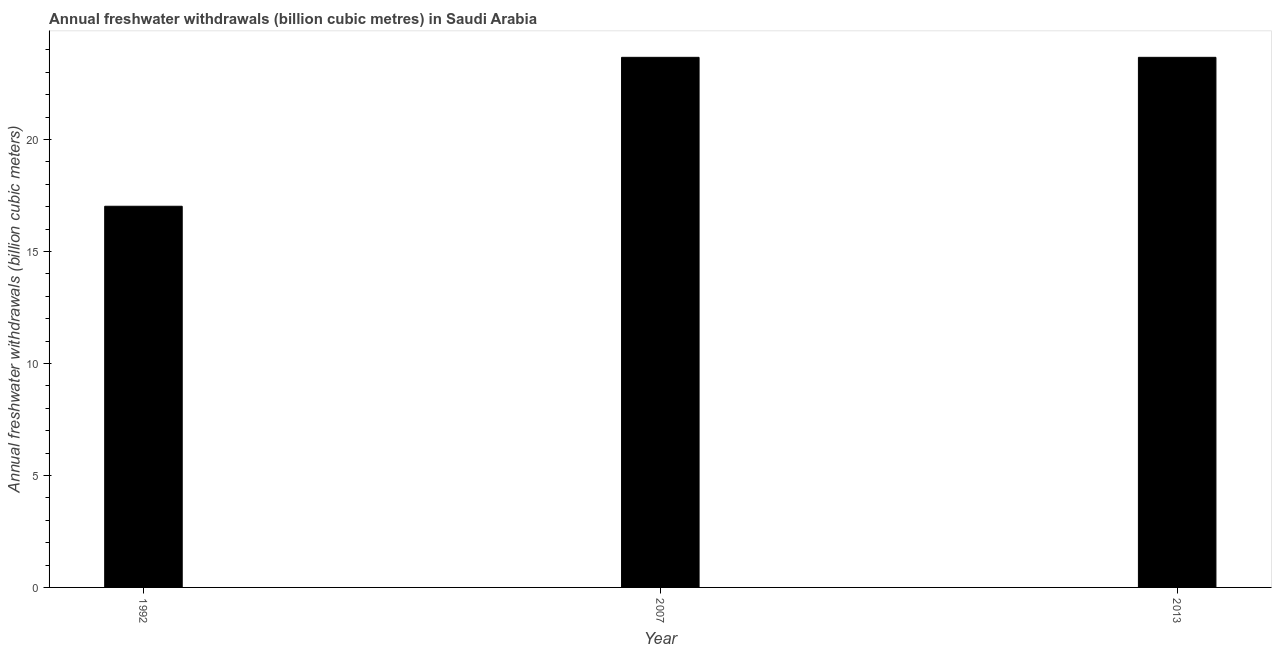Does the graph contain any zero values?
Offer a terse response. No. What is the title of the graph?
Give a very brief answer. Annual freshwater withdrawals (billion cubic metres) in Saudi Arabia. What is the label or title of the Y-axis?
Your response must be concise. Annual freshwater withdrawals (billion cubic meters). What is the annual freshwater withdrawals in 1992?
Ensure brevity in your answer.  17.02. Across all years, what is the maximum annual freshwater withdrawals?
Your answer should be compact. 23.67. Across all years, what is the minimum annual freshwater withdrawals?
Provide a succinct answer. 17.02. In which year was the annual freshwater withdrawals maximum?
Make the answer very short. 2007. In which year was the annual freshwater withdrawals minimum?
Give a very brief answer. 1992. What is the sum of the annual freshwater withdrawals?
Your answer should be very brief. 64.36. What is the difference between the annual freshwater withdrawals in 1992 and 2013?
Offer a terse response. -6.65. What is the average annual freshwater withdrawals per year?
Offer a very short reply. 21.45. What is the median annual freshwater withdrawals?
Offer a terse response. 23.67. In how many years, is the annual freshwater withdrawals greater than 22 billion cubic meters?
Provide a succinct answer. 2. What is the ratio of the annual freshwater withdrawals in 1992 to that in 2007?
Your answer should be compact. 0.72. Is the annual freshwater withdrawals in 1992 less than that in 2007?
Offer a terse response. Yes. What is the difference between the highest and the second highest annual freshwater withdrawals?
Give a very brief answer. 0. Is the sum of the annual freshwater withdrawals in 1992 and 2013 greater than the maximum annual freshwater withdrawals across all years?
Provide a succinct answer. Yes. What is the difference between the highest and the lowest annual freshwater withdrawals?
Provide a short and direct response. 6.65. How many bars are there?
Offer a very short reply. 3. Are all the bars in the graph horizontal?
Keep it short and to the point. No. What is the Annual freshwater withdrawals (billion cubic meters) of 1992?
Your answer should be very brief. 17.02. What is the Annual freshwater withdrawals (billion cubic meters) in 2007?
Offer a very short reply. 23.67. What is the Annual freshwater withdrawals (billion cubic meters) in 2013?
Offer a very short reply. 23.67. What is the difference between the Annual freshwater withdrawals (billion cubic meters) in 1992 and 2007?
Your response must be concise. -6.65. What is the difference between the Annual freshwater withdrawals (billion cubic meters) in 1992 and 2013?
Offer a terse response. -6.65. What is the ratio of the Annual freshwater withdrawals (billion cubic meters) in 1992 to that in 2007?
Keep it short and to the point. 0.72. What is the ratio of the Annual freshwater withdrawals (billion cubic meters) in 1992 to that in 2013?
Give a very brief answer. 0.72. What is the ratio of the Annual freshwater withdrawals (billion cubic meters) in 2007 to that in 2013?
Your answer should be very brief. 1. 